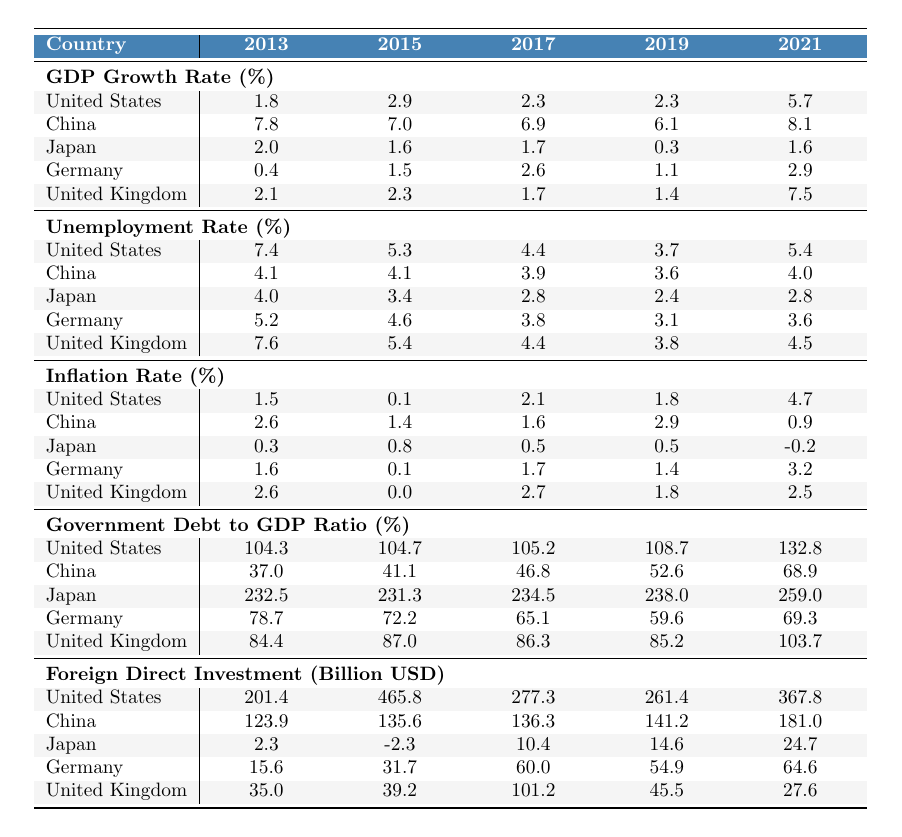What was the unemployment rate in Germany in 2019? The table shows the unemployment rate for Germany in 2019, which is listed under the "Unemployment Rate (%)" row corresponding to the year 2019. The value is 3.1.
Answer: 3.1 What is the inflation rate for Japan in 2021? The table indicates the inflation rate for Japan in 2021, found in the "Inflation Rate (%)" row for that year. The value is -0.2.
Answer: -0.2 Which country had the highest GDP growth rate in 2021? By comparing the GDP growth rates for all countries in 2021, the maximum value is found for India, which is 8.9.
Answer: India What is the average unemployment rate for the United States over the years provided? The unemployment rates for the United States in the years provided are 7.4, 5.3, 4.4, 3.7, and 5.4. We sum these values (7.4 + 5.3 + 4.4 + 3.7 + 5.4 = 26.2) and then divide by the number of years (5) to get an average of 26.2 / 5 = 5.24.
Answer: 5.24 Which country experienced the largest increase in Foreign Direct Investment from 2013 to 2021? Looking at the "Foreign Direct Investment (Billion USD)" values, for the U.S. it increased from 201.4 to 367.8, for China from 123.9 to 181.0, and similar calculations for others. The largest increase is 367.8 - 201.4 = 166.4 for the United States.
Answer: United States Is it true that France had a higher GDP growth rate than Germany in 2021? The GDP growth rate for France in 2021 is 7.0, while for Germany, it is 2.9. Since 7.0 > 2.9, the statement is true.
Answer: Yes What was the difference in the government debt to GDP ratio between Japan and Germany in 2021? Japan's ratio in 2021 is 259.0, and Germany's is 69.3. To find the difference, we calculate 259.0 - 69.3 = 189.7.
Answer: 189.7 Which country's inflation rate saw a decline from 2013 to 2015? By examining the inflation rates for each country between 2013 and 2015, we find that Japan's rate fell from 0.3 to 0.1.
Answer: Japan Calculate the average GDP growth rate for India over the provided years. India's GDP growth rates are 6.4, 8.0, 6.8, 4.0, and 8.9. Summing these values gives 6.4 + 8.0 + 6.8 + 4.0 + 8.9 = 34.1. Dividing by 5 yields an average of 34.1 / 5 = 6.82.
Answer: 6.82 Which country had the lowest unemployment rate in 2017? In 2017, the unemployment rates for each country are listed, with the lowest being Japan at 2.8.
Answer: Japan Did Brazil's GDP growth rate ever rise above 3% in the years provided? The recorded GDP growth rates for Brazil are 3.0, -3.5, 1.3, 1.4, and 4.6. The highest rate is 4.6, which is above 3%.
Answer: Yes 